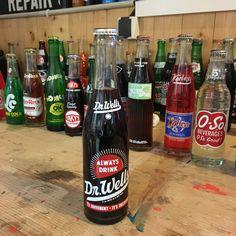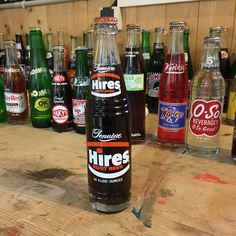The first image is the image on the left, the second image is the image on the right. For the images displayed, is the sentence "The left image features one green bottle of soda standing in front of rows of bottles, and the right image features one clear bottle of brown cola standing in front of rows of bottles." factually correct? Answer yes or no. No. 